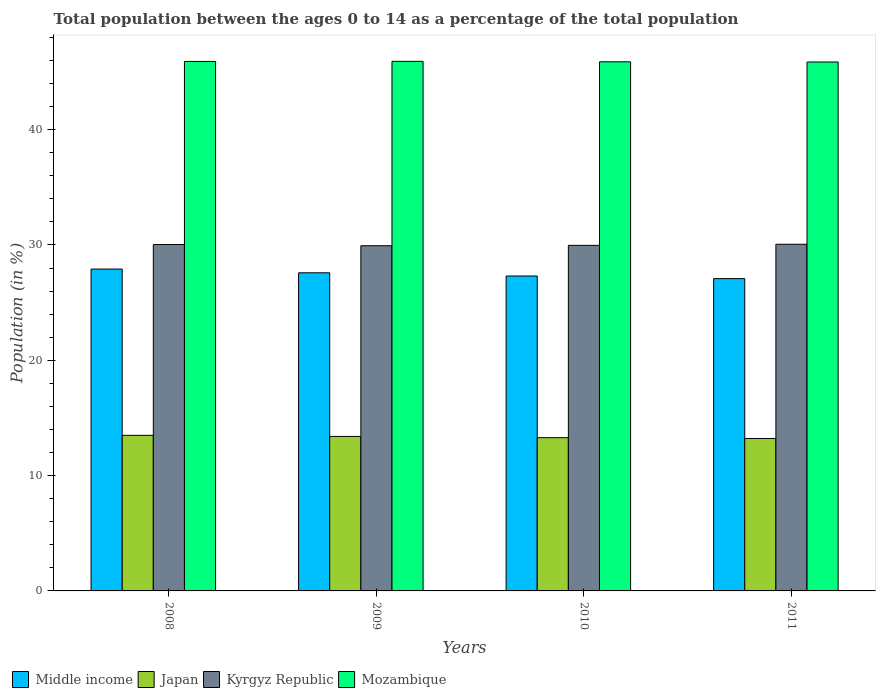How many groups of bars are there?
Provide a short and direct response. 4. Are the number of bars on each tick of the X-axis equal?
Give a very brief answer. Yes. How many bars are there on the 2nd tick from the left?
Keep it short and to the point. 4. How many bars are there on the 1st tick from the right?
Give a very brief answer. 4. What is the percentage of the population ages 0 to 14 in Middle income in 2009?
Your response must be concise. 27.59. Across all years, what is the maximum percentage of the population ages 0 to 14 in Kyrgyz Republic?
Provide a succinct answer. 30.06. Across all years, what is the minimum percentage of the population ages 0 to 14 in Mozambique?
Keep it short and to the point. 45.87. What is the total percentage of the population ages 0 to 14 in Japan in the graph?
Keep it short and to the point. 53.4. What is the difference between the percentage of the population ages 0 to 14 in Japan in 2009 and that in 2011?
Your answer should be very brief. 0.18. What is the difference between the percentage of the population ages 0 to 14 in Mozambique in 2008 and the percentage of the population ages 0 to 14 in Kyrgyz Republic in 2009?
Offer a terse response. 15.98. What is the average percentage of the population ages 0 to 14 in Middle income per year?
Your answer should be compact. 27.47. In the year 2011, what is the difference between the percentage of the population ages 0 to 14 in Kyrgyz Republic and percentage of the population ages 0 to 14 in Middle income?
Your answer should be compact. 2.98. What is the ratio of the percentage of the population ages 0 to 14 in Mozambique in 2008 to that in 2010?
Your answer should be compact. 1. Is the percentage of the population ages 0 to 14 in Kyrgyz Republic in 2009 less than that in 2010?
Ensure brevity in your answer.  Yes. What is the difference between the highest and the second highest percentage of the population ages 0 to 14 in Mozambique?
Offer a terse response. 0.01. What is the difference between the highest and the lowest percentage of the population ages 0 to 14 in Mozambique?
Provide a short and direct response. 0.06. In how many years, is the percentage of the population ages 0 to 14 in Mozambique greater than the average percentage of the population ages 0 to 14 in Mozambique taken over all years?
Your response must be concise. 2. Is the sum of the percentage of the population ages 0 to 14 in Kyrgyz Republic in 2008 and 2010 greater than the maximum percentage of the population ages 0 to 14 in Mozambique across all years?
Give a very brief answer. Yes. What does the 1st bar from the left in 2010 represents?
Your response must be concise. Middle income. What does the 3rd bar from the right in 2010 represents?
Offer a terse response. Japan. How many bars are there?
Give a very brief answer. 16. Are all the bars in the graph horizontal?
Keep it short and to the point. No. What is the difference between two consecutive major ticks on the Y-axis?
Your answer should be compact. 10. Does the graph contain any zero values?
Offer a terse response. No. Does the graph contain grids?
Offer a terse response. No. How many legend labels are there?
Provide a succinct answer. 4. What is the title of the graph?
Keep it short and to the point. Total population between the ages 0 to 14 as a percentage of the total population. What is the label or title of the X-axis?
Offer a terse response. Years. What is the label or title of the Y-axis?
Make the answer very short. Population (in %). What is the Population (in %) in Middle income in 2008?
Offer a very short reply. 27.91. What is the Population (in %) of Japan in 2008?
Provide a short and direct response. 13.49. What is the Population (in %) in Kyrgyz Republic in 2008?
Provide a short and direct response. 30.04. What is the Population (in %) of Mozambique in 2008?
Your response must be concise. 45.92. What is the Population (in %) in Middle income in 2009?
Offer a terse response. 27.59. What is the Population (in %) of Japan in 2009?
Keep it short and to the point. 13.4. What is the Population (in %) of Kyrgyz Republic in 2009?
Offer a terse response. 29.94. What is the Population (in %) of Mozambique in 2009?
Offer a terse response. 45.93. What is the Population (in %) in Middle income in 2010?
Make the answer very short. 27.31. What is the Population (in %) in Japan in 2010?
Ensure brevity in your answer.  13.29. What is the Population (in %) of Kyrgyz Republic in 2010?
Offer a very short reply. 29.97. What is the Population (in %) in Mozambique in 2010?
Provide a succinct answer. 45.89. What is the Population (in %) of Middle income in 2011?
Keep it short and to the point. 27.08. What is the Population (in %) of Japan in 2011?
Offer a very short reply. 13.22. What is the Population (in %) in Kyrgyz Republic in 2011?
Ensure brevity in your answer.  30.06. What is the Population (in %) in Mozambique in 2011?
Make the answer very short. 45.87. Across all years, what is the maximum Population (in %) in Middle income?
Offer a very short reply. 27.91. Across all years, what is the maximum Population (in %) of Japan?
Offer a very short reply. 13.49. Across all years, what is the maximum Population (in %) of Kyrgyz Republic?
Your answer should be very brief. 30.06. Across all years, what is the maximum Population (in %) in Mozambique?
Offer a very short reply. 45.93. Across all years, what is the minimum Population (in %) in Middle income?
Keep it short and to the point. 27.08. Across all years, what is the minimum Population (in %) in Japan?
Make the answer very short. 13.22. Across all years, what is the minimum Population (in %) in Kyrgyz Republic?
Your answer should be compact. 29.94. Across all years, what is the minimum Population (in %) in Mozambique?
Offer a very short reply. 45.87. What is the total Population (in %) of Middle income in the graph?
Ensure brevity in your answer.  109.89. What is the total Population (in %) of Japan in the graph?
Your answer should be compact. 53.4. What is the total Population (in %) in Kyrgyz Republic in the graph?
Give a very brief answer. 120.01. What is the total Population (in %) of Mozambique in the graph?
Provide a short and direct response. 183.6. What is the difference between the Population (in %) of Middle income in 2008 and that in 2009?
Offer a very short reply. 0.32. What is the difference between the Population (in %) of Japan in 2008 and that in 2009?
Give a very brief answer. 0.09. What is the difference between the Population (in %) of Kyrgyz Republic in 2008 and that in 2009?
Offer a terse response. 0.1. What is the difference between the Population (in %) in Mozambique in 2008 and that in 2009?
Give a very brief answer. -0.01. What is the difference between the Population (in %) in Middle income in 2008 and that in 2010?
Provide a short and direct response. 0.6. What is the difference between the Population (in %) in Japan in 2008 and that in 2010?
Give a very brief answer. 0.2. What is the difference between the Population (in %) in Kyrgyz Republic in 2008 and that in 2010?
Your answer should be very brief. 0.07. What is the difference between the Population (in %) in Mozambique in 2008 and that in 2010?
Your answer should be very brief. 0.03. What is the difference between the Population (in %) in Middle income in 2008 and that in 2011?
Your response must be concise. 0.83. What is the difference between the Population (in %) in Japan in 2008 and that in 2011?
Offer a terse response. 0.27. What is the difference between the Population (in %) in Kyrgyz Republic in 2008 and that in 2011?
Offer a terse response. -0.02. What is the difference between the Population (in %) of Mozambique in 2008 and that in 2011?
Provide a short and direct response. 0.05. What is the difference between the Population (in %) in Middle income in 2009 and that in 2010?
Offer a terse response. 0.28. What is the difference between the Population (in %) of Japan in 2009 and that in 2010?
Give a very brief answer. 0.11. What is the difference between the Population (in %) of Kyrgyz Republic in 2009 and that in 2010?
Keep it short and to the point. -0.03. What is the difference between the Population (in %) of Mozambique in 2009 and that in 2010?
Your response must be concise. 0.04. What is the difference between the Population (in %) in Middle income in 2009 and that in 2011?
Provide a succinct answer. 0.5. What is the difference between the Population (in %) of Japan in 2009 and that in 2011?
Your answer should be compact. 0.18. What is the difference between the Population (in %) of Kyrgyz Republic in 2009 and that in 2011?
Your answer should be compact. -0.13. What is the difference between the Population (in %) of Mozambique in 2009 and that in 2011?
Keep it short and to the point. 0.06. What is the difference between the Population (in %) of Middle income in 2010 and that in 2011?
Provide a succinct answer. 0.23. What is the difference between the Population (in %) in Japan in 2010 and that in 2011?
Offer a very short reply. 0.07. What is the difference between the Population (in %) in Kyrgyz Republic in 2010 and that in 2011?
Your answer should be compact. -0.09. What is the difference between the Population (in %) in Mozambique in 2010 and that in 2011?
Offer a very short reply. 0.02. What is the difference between the Population (in %) in Middle income in 2008 and the Population (in %) in Japan in 2009?
Make the answer very short. 14.51. What is the difference between the Population (in %) of Middle income in 2008 and the Population (in %) of Kyrgyz Republic in 2009?
Give a very brief answer. -2.02. What is the difference between the Population (in %) of Middle income in 2008 and the Population (in %) of Mozambique in 2009?
Your answer should be very brief. -18.01. What is the difference between the Population (in %) of Japan in 2008 and the Population (in %) of Kyrgyz Republic in 2009?
Keep it short and to the point. -16.44. What is the difference between the Population (in %) of Japan in 2008 and the Population (in %) of Mozambique in 2009?
Make the answer very short. -32.43. What is the difference between the Population (in %) of Kyrgyz Republic in 2008 and the Population (in %) of Mozambique in 2009?
Your answer should be compact. -15.89. What is the difference between the Population (in %) in Middle income in 2008 and the Population (in %) in Japan in 2010?
Offer a terse response. 14.62. What is the difference between the Population (in %) of Middle income in 2008 and the Population (in %) of Kyrgyz Republic in 2010?
Make the answer very short. -2.06. What is the difference between the Population (in %) in Middle income in 2008 and the Population (in %) in Mozambique in 2010?
Your answer should be very brief. -17.97. What is the difference between the Population (in %) of Japan in 2008 and the Population (in %) of Kyrgyz Republic in 2010?
Make the answer very short. -16.48. What is the difference between the Population (in %) in Japan in 2008 and the Population (in %) in Mozambique in 2010?
Ensure brevity in your answer.  -32.4. What is the difference between the Population (in %) of Kyrgyz Republic in 2008 and the Population (in %) of Mozambique in 2010?
Provide a succinct answer. -15.85. What is the difference between the Population (in %) in Middle income in 2008 and the Population (in %) in Japan in 2011?
Keep it short and to the point. 14.69. What is the difference between the Population (in %) of Middle income in 2008 and the Population (in %) of Kyrgyz Republic in 2011?
Give a very brief answer. -2.15. What is the difference between the Population (in %) in Middle income in 2008 and the Population (in %) in Mozambique in 2011?
Offer a very short reply. -17.96. What is the difference between the Population (in %) in Japan in 2008 and the Population (in %) in Kyrgyz Republic in 2011?
Your answer should be compact. -16.57. What is the difference between the Population (in %) in Japan in 2008 and the Population (in %) in Mozambique in 2011?
Make the answer very short. -32.38. What is the difference between the Population (in %) in Kyrgyz Republic in 2008 and the Population (in %) in Mozambique in 2011?
Provide a succinct answer. -15.83. What is the difference between the Population (in %) in Middle income in 2009 and the Population (in %) in Japan in 2010?
Offer a terse response. 14.3. What is the difference between the Population (in %) in Middle income in 2009 and the Population (in %) in Kyrgyz Republic in 2010?
Offer a very short reply. -2.38. What is the difference between the Population (in %) of Middle income in 2009 and the Population (in %) of Mozambique in 2010?
Offer a terse response. -18.3. What is the difference between the Population (in %) of Japan in 2009 and the Population (in %) of Kyrgyz Republic in 2010?
Ensure brevity in your answer.  -16.57. What is the difference between the Population (in %) in Japan in 2009 and the Population (in %) in Mozambique in 2010?
Make the answer very short. -32.49. What is the difference between the Population (in %) in Kyrgyz Republic in 2009 and the Population (in %) in Mozambique in 2010?
Offer a very short reply. -15.95. What is the difference between the Population (in %) in Middle income in 2009 and the Population (in %) in Japan in 2011?
Offer a terse response. 14.37. What is the difference between the Population (in %) of Middle income in 2009 and the Population (in %) of Kyrgyz Republic in 2011?
Your answer should be very brief. -2.47. What is the difference between the Population (in %) of Middle income in 2009 and the Population (in %) of Mozambique in 2011?
Give a very brief answer. -18.28. What is the difference between the Population (in %) of Japan in 2009 and the Population (in %) of Kyrgyz Republic in 2011?
Provide a short and direct response. -16.66. What is the difference between the Population (in %) in Japan in 2009 and the Population (in %) in Mozambique in 2011?
Your answer should be very brief. -32.47. What is the difference between the Population (in %) of Kyrgyz Republic in 2009 and the Population (in %) of Mozambique in 2011?
Offer a very short reply. -15.93. What is the difference between the Population (in %) in Middle income in 2010 and the Population (in %) in Japan in 2011?
Provide a succinct answer. 14.09. What is the difference between the Population (in %) of Middle income in 2010 and the Population (in %) of Kyrgyz Republic in 2011?
Offer a very short reply. -2.75. What is the difference between the Population (in %) of Middle income in 2010 and the Population (in %) of Mozambique in 2011?
Your answer should be compact. -18.56. What is the difference between the Population (in %) of Japan in 2010 and the Population (in %) of Kyrgyz Republic in 2011?
Provide a succinct answer. -16.77. What is the difference between the Population (in %) in Japan in 2010 and the Population (in %) in Mozambique in 2011?
Make the answer very short. -32.58. What is the difference between the Population (in %) in Kyrgyz Republic in 2010 and the Population (in %) in Mozambique in 2011?
Your answer should be very brief. -15.9. What is the average Population (in %) of Middle income per year?
Offer a terse response. 27.47. What is the average Population (in %) of Japan per year?
Make the answer very short. 13.35. What is the average Population (in %) of Kyrgyz Republic per year?
Make the answer very short. 30. What is the average Population (in %) of Mozambique per year?
Your response must be concise. 45.9. In the year 2008, what is the difference between the Population (in %) of Middle income and Population (in %) of Japan?
Your answer should be compact. 14.42. In the year 2008, what is the difference between the Population (in %) in Middle income and Population (in %) in Kyrgyz Republic?
Your answer should be compact. -2.13. In the year 2008, what is the difference between the Population (in %) in Middle income and Population (in %) in Mozambique?
Keep it short and to the point. -18.01. In the year 2008, what is the difference between the Population (in %) in Japan and Population (in %) in Kyrgyz Republic?
Provide a succinct answer. -16.55. In the year 2008, what is the difference between the Population (in %) in Japan and Population (in %) in Mozambique?
Your response must be concise. -32.43. In the year 2008, what is the difference between the Population (in %) of Kyrgyz Republic and Population (in %) of Mozambique?
Your answer should be compact. -15.88. In the year 2009, what is the difference between the Population (in %) of Middle income and Population (in %) of Japan?
Give a very brief answer. 14.19. In the year 2009, what is the difference between the Population (in %) in Middle income and Population (in %) in Kyrgyz Republic?
Your answer should be very brief. -2.35. In the year 2009, what is the difference between the Population (in %) in Middle income and Population (in %) in Mozambique?
Your answer should be very brief. -18.34. In the year 2009, what is the difference between the Population (in %) in Japan and Population (in %) in Kyrgyz Republic?
Provide a short and direct response. -16.54. In the year 2009, what is the difference between the Population (in %) in Japan and Population (in %) in Mozambique?
Provide a short and direct response. -32.53. In the year 2009, what is the difference between the Population (in %) of Kyrgyz Republic and Population (in %) of Mozambique?
Keep it short and to the point. -15.99. In the year 2010, what is the difference between the Population (in %) of Middle income and Population (in %) of Japan?
Your answer should be very brief. 14.02. In the year 2010, what is the difference between the Population (in %) of Middle income and Population (in %) of Kyrgyz Republic?
Provide a succinct answer. -2.66. In the year 2010, what is the difference between the Population (in %) in Middle income and Population (in %) in Mozambique?
Provide a short and direct response. -18.58. In the year 2010, what is the difference between the Population (in %) of Japan and Population (in %) of Kyrgyz Republic?
Make the answer very short. -16.68. In the year 2010, what is the difference between the Population (in %) in Japan and Population (in %) in Mozambique?
Make the answer very short. -32.6. In the year 2010, what is the difference between the Population (in %) in Kyrgyz Republic and Population (in %) in Mozambique?
Provide a short and direct response. -15.92. In the year 2011, what is the difference between the Population (in %) in Middle income and Population (in %) in Japan?
Offer a very short reply. 13.86. In the year 2011, what is the difference between the Population (in %) in Middle income and Population (in %) in Kyrgyz Republic?
Provide a short and direct response. -2.98. In the year 2011, what is the difference between the Population (in %) in Middle income and Population (in %) in Mozambique?
Offer a terse response. -18.78. In the year 2011, what is the difference between the Population (in %) in Japan and Population (in %) in Kyrgyz Republic?
Provide a succinct answer. -16.84. In the year 2011, what is the difference between the Population (in %) of Japan and Population (in %) of Mozambique?
Offer a terse response. -32.65. In the year 2011, what is the difference between the Population (in %) in Kyrgyz Republic and Population (in %) in Mozambique?
Offer a terse response. -15.81. What is the ratio of the Population (in %) in Middle income in 2008 to that in 2009?
Make the answer very short. 1.01. What is the ratio of the Population (in %) in Japan in 2008 to that in 2009?
Your answer should be very brief. 1.01. What is the ratio of the Population (in %) in Kyrgyz Republic in 2008 to that in 2009?
Keep it short and to the point. 1. What is the ratio of the Population (in %) of Mozambique in 2008 to that in 2009?
Provide a short and direct response. 1. What is the ratio of the Population (in %) of Japan in 2008 to that in 2010?
Provide a short and direct response. 1.02. What is the ratio of the Population (in %) in Kyrgyz Republic in 2008 to that in 2010?
Offer a very short reply. 1. What is the ratio of the Population (in %) of Mozambique in 2008 to that in 2010?
Give a very brief answer. 1. What is the ratio of the Population (in %) in Middle income in 2008 to that in 2011?
Provide a short and direct response. 1.03. What is the ratio of the Population (in %) in Japan in 2008 to that in 2011?
Your answer should be compact. 1.02. What is the ratio of the Population (in %) in Mozambique in 2008 to that in 2011?
Your answer should be very brief. 1. What is the ratio of the Population (in %) of Middle income in 2009 to that in 2010?
Your answer should be very brief. 1.01. What is the ratio of the Population (in %) of Mozambique in 2009 to that in 2010?
Make the answer very short. 1. What is the ratio of the Population (in %) of Middle income in 2009 to that in 2011?
Give a very brief answer. 1.02. What is the ratio of the Population (in %) in Japan in 2009 to that in 2011?
Make the answer very short. 1.01. What is the ratio of the Population (in %) in Middle income in 2010 to that in 2011?
Provide a succinct answer. 1.01. What is the ratio of the Population (in %) in Japan in 2010 to that in 2011?
Keep it short and to the point. 1.01. What is the ratio of the Population (in %) of Kyrgyz Republic in 2010 to that in 2011?
Offer a terse response. 1. What is the ratio of the Population (in %) of Mozambique in 2010 to that in 2011?
Your response must be concise. 1. What is the difference between the highest and the second highest Population (in %) of Middle income?
Your answer should be very brief. 0.32. What is the difference between the highest and the second highest Population (in %) of Japan?
Your response must be concise. 0.09. What is the difference between the highest and the second highest Population (in %) of Kyrgyz Republic?
Ensure brevity in your answer.  0.02. What is the difference between the highest and the second highest Population (in %) in Mozambique?
Ensure brevity in your answer.  0.01. What is the difference between the highest and the lowest Population (in %) in Middle income?
Keep it short and to the point. 0.83. What is the difference between the highest and the lowest Population (in %) in Japan?
Keep it short and to the point. 0.27. What is the difference between the highest and the lowest Population (in %) of Kyrgyz Republic?
Provide a short and direct response. 0.13. What is the difference between the highest and the lowest Population (in %) of Mozambique?
Keep it short and to the point. 0.06. 